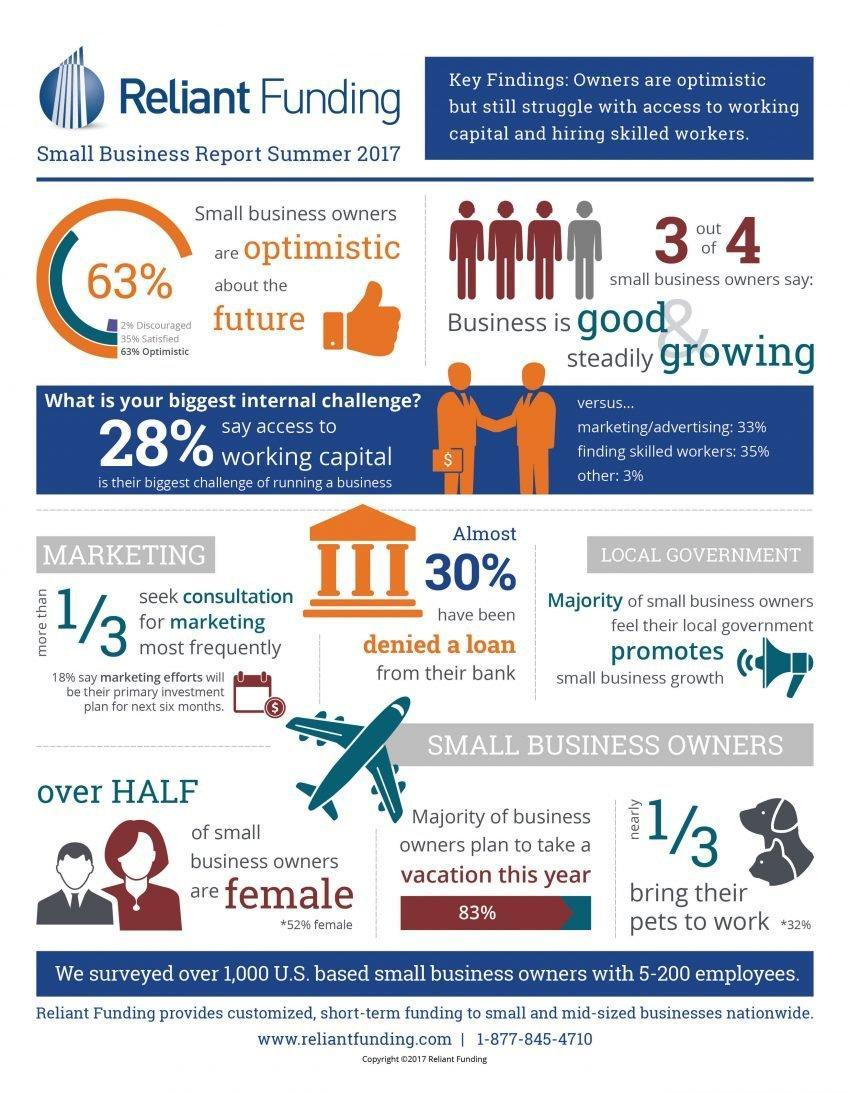What percent of small business owners say that marketing or advertising is their biggest challenge of running a business as per the small business report summer 2017?
Answer the question with a short phrase. 33% What percent of business owners plan to take a vacation this year as per the small business report summer 2017? 83% What percent of small business owners are female according to the small business report summer 2017? 52% What percent of small business owners say that finding skilled workers is their biggest challenge of running a business as per the small business report summer 2017? 35% What percentage of small business owners were satisfied about the future according to the small business report summer 2017? 35% What percentage of small business owners were discouraged about the future according to the small business report summer 2017? 2% 